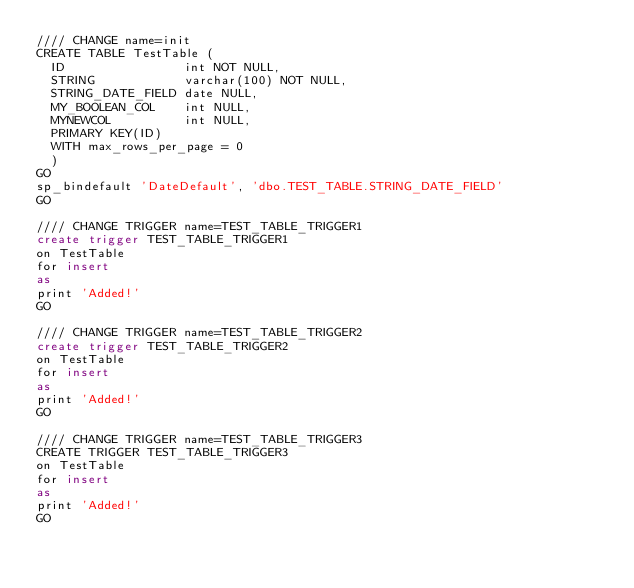Convert code to text. <code><loc_0><loc_0><loc_500><loc_500><_SQL_>//// CHANGE name=init
CREATE TABLE TestTable (
	ID               	int NOT NULL,
	STRING           	varchar(100) NOT NULL,
	STRING_DATE_FIELD	date NULL,
	MY_BOOLEAN_COL   	int NULL,
	MYNEWCOL         	int NULL,
	PRIMARY KEY(ID)
	WITH max_rows_per_page = 0
	)
GO
sp_bindefault 'DateDefault', 'dbo.TEST_TABLE.STRING_DATE_FIELD'
GO

//// CHANGE TRIGGER name=TEST_TABLE_TRIGGER1
create trigger TEST_TABLE_TRIGGER1
on TestTable
for insert
as
print 'Added!'
GO

//// CHANGE TRIGGER name=TEST_TABLE_TRIGGER2
create trigger TEST_TABLE_TRIGGER2
on TestTable
for insert
as
print 'Added!'
GO

//// CHANGE TRIGGER name=TEST_TABLE_TRIGGER3
CREATE TRIGGER TEST_TABLE_TRIGGER3
on TestTable
for insert
as
print 'Added!'
GO
</code> 